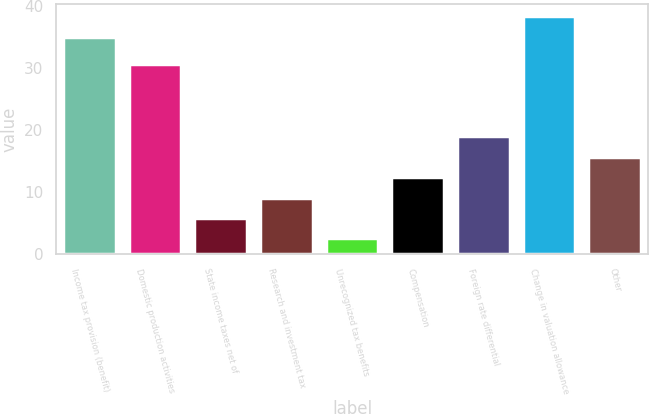<chart> <loc_0><loc_0><loc_500><loc_500><bar_chart><fcel>Income tax provision (benefit)<fcel>Domestic production activities<fcel>State income taxes net of<fcel>Research and investment tax<fcel>Unrecognized tax benefits<fcel>Compensation<fcel>Foreign rate differential<fcel>Change in valuation allowance<fcel>Other<nl><fcel>35<fcel>30.6<fcel>5.79<fcel>9.08<fcel>2.5<fcel>12.37<fcel>18.95<fcel>38.29<fcel>15.66<nl></chart> 